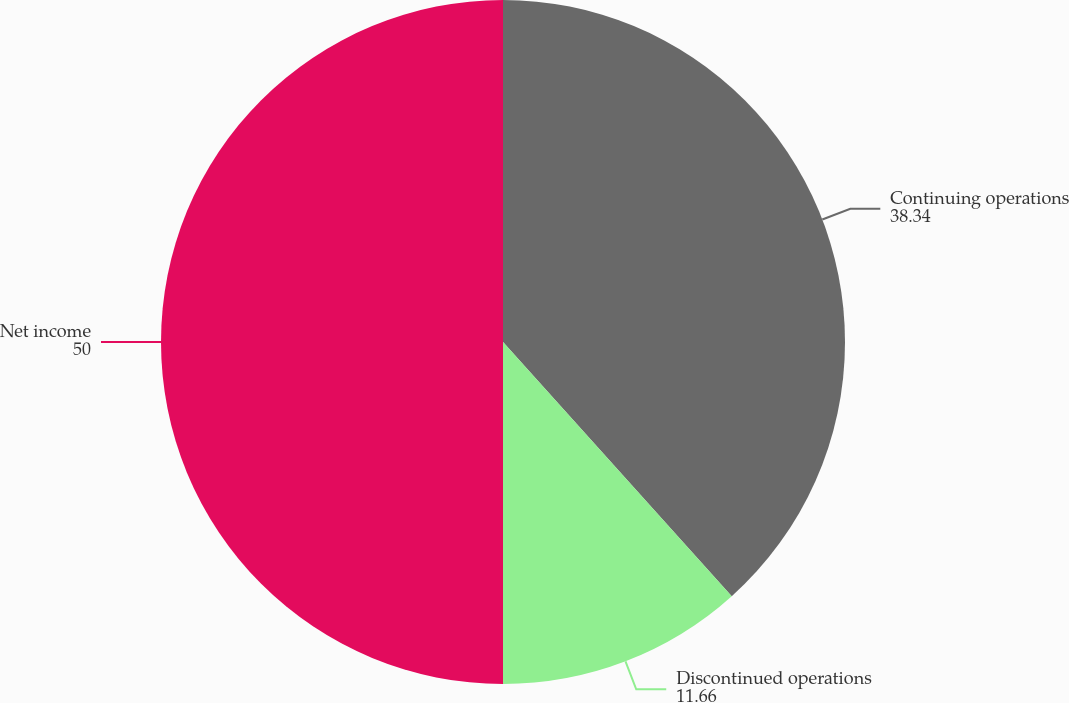Convert chart. <chart><loc_0><loc_0><loc_500><loc_500><pie_chart><fcel>Continuing operations<fcel>Discontinued operations<fcel>Net income<nl><fcel>38.34%<fcel>11.66%<fcel>50.0%<nl></chart> 